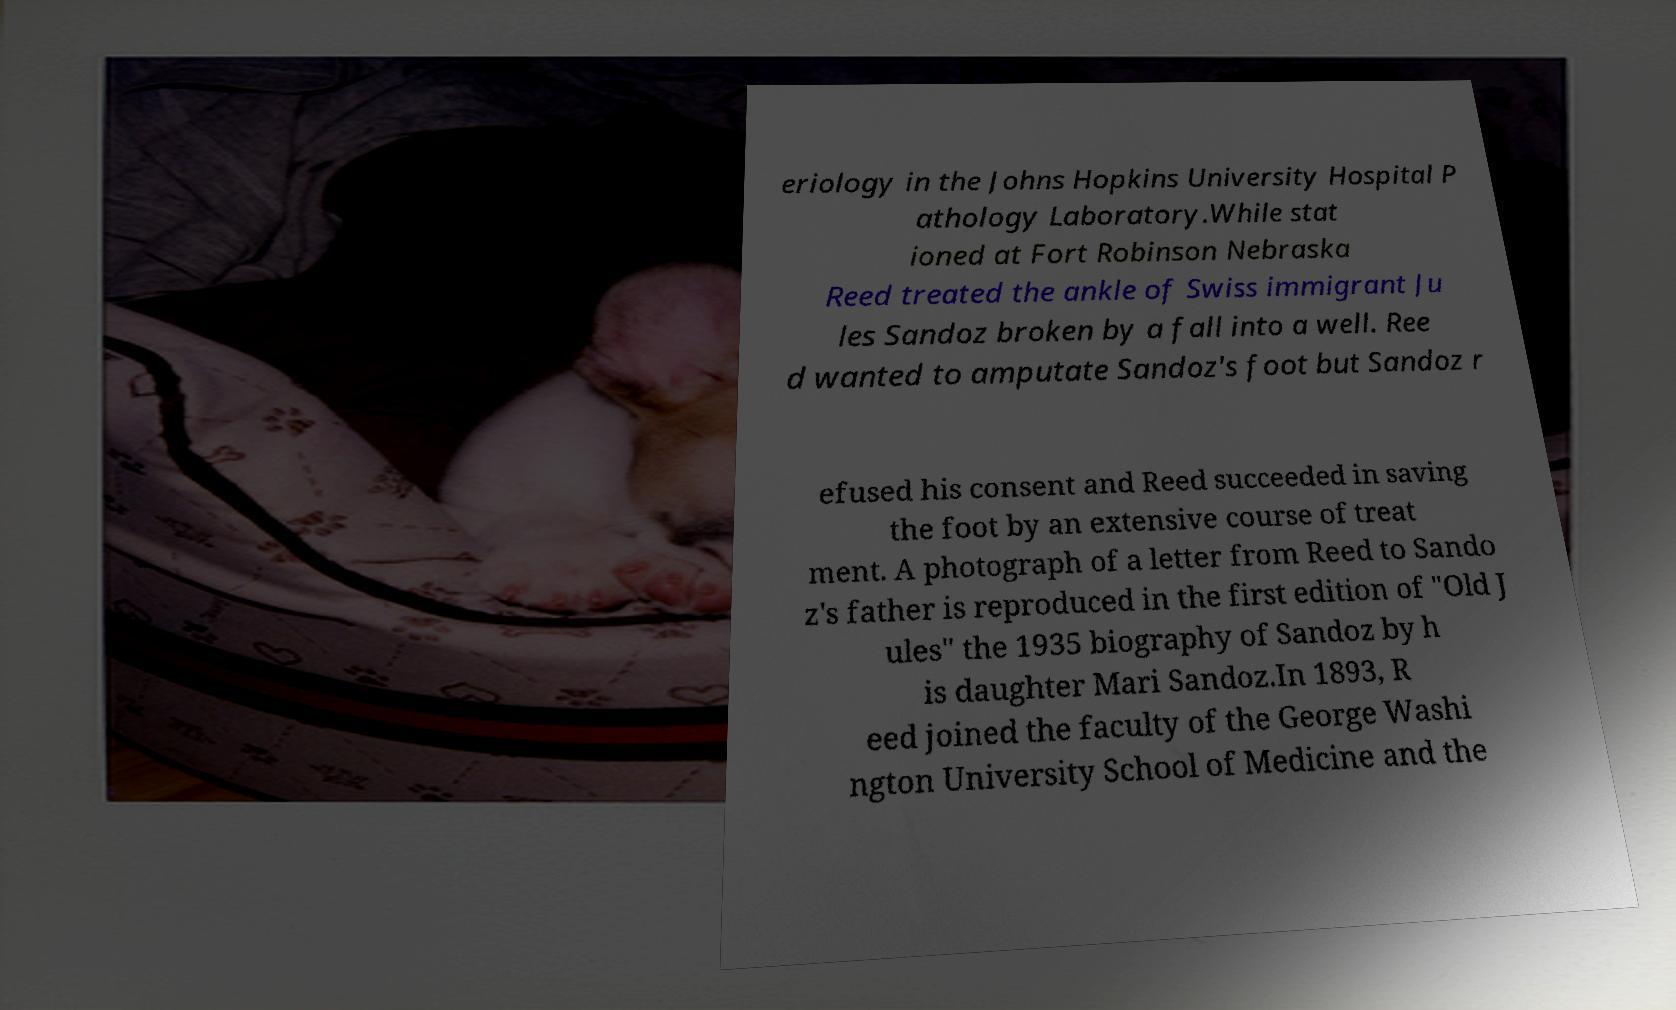Please read and relay the text visible in this image. What does it say? eriology in the Johns Hopkins University Hospital P athology Laboratory.While stat ioned at Fort Robinson Nebraska Reed treated the ankle of Swiss immigrant Ju les Sandoz broken by a fall into a well. Ree d wanted to amputate Sandoz's foot but Sandoz r efused his consent and Reed succeeded in saving the foot by an extensive course of treat ment. A photograph of a letter from Reed to Sando z's father is reproduced in the first edition of "Old J ules" the 1935 biography of Sandoz by h is daughter Mari Sandoz.In 1893, R eed joined the faculty of the George Washi ngton University School of Medicine and the 